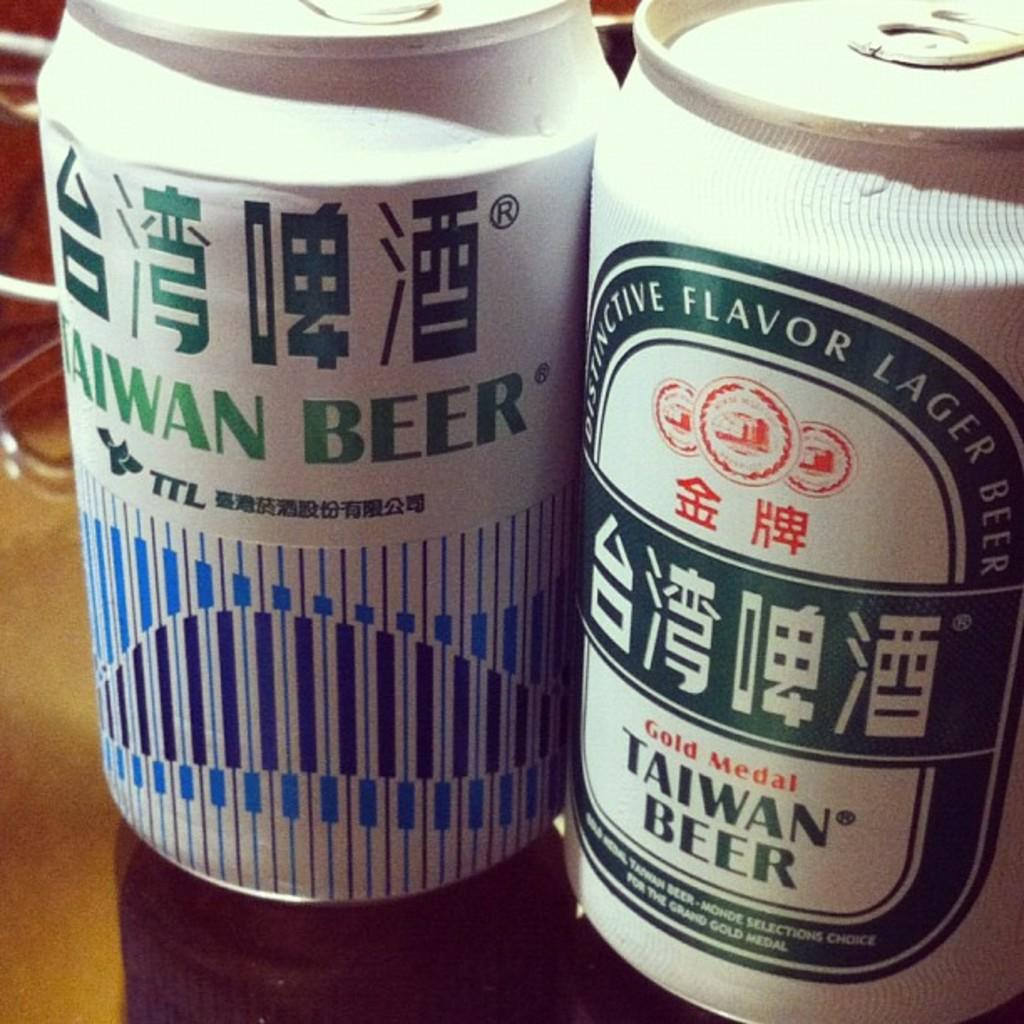<image>
Describe the image concisely. A can with Taiwan Beer sits next to a can with Gold Medal Taiwan Beer 